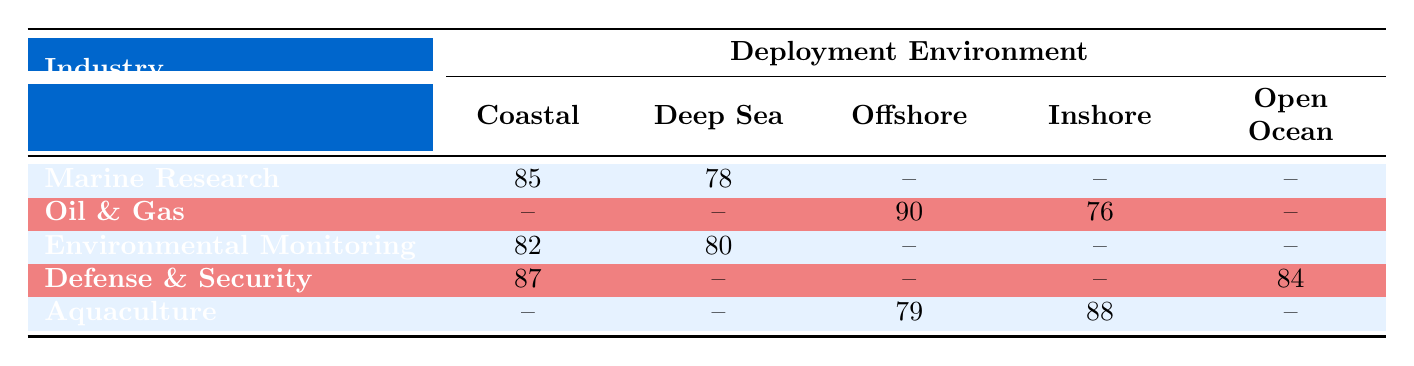What is the satisfaction rating for Marine Research in the Coastal environment? The table shows that the satisfaction rating for Marine Research under the Coastal deployment environment is 85.
Answer: 85 What is the satisfaction rating for Aquaculture in the Inshore environment? According to the table, Aquaculture has a satisfaction rating of 88 in the Inshore deployment environment.
Answer: 88 Which industry has the highest satisfaction rating in the Offshore environment? The table indicates that the Oil & Gas industry has a satisfaction rating of 90 in the Offshore deployment environment, which is the highest among all industries listed.
Answer: 90 What is the average satisfaction rating for the Environmental Monitoring industry? The satisfaction ratings for Environmental Monitoring are 82 (Coastal) and 80 (Deep Sea). Adding these gives 162, and dividing by 2 gives an average of 81.
Answer: 81 Is there a satisfaction rating recorded for Oil & Gas in the Coastal environment? The table shows no satisfaction rating listed for Oil & Gas in the Coastal environment, indicating that it is not applicable or data is not available.
Answer: No What is the difference between the satisfaction ratings of Defense & Security in the Coastal and Open Ocean environments? The rating for Defense & Security in the Coastal environment is 87, and in the Open Ocean environment is 84. The difference is 87 - 84 = 3.
Answer: 3 Which industries have data for both Coastal and Deep Sea environments? The table indicates only Marine Research and Environmental Monitoring have satisfaction ratings for both Coastal (Marine Research: 85, Environmental Monitoring: 82) and Deep Sea (Marine Research: 78, Environmental Monitoring: 80) environments.
Answer: Marine Research, Environmental Monitoring Is the satisfaction rating for Aquaculture lower in Offshore than in Inshore environments? The table highlights that Aquaculture has a satisfaction rating of 79 in the Offshore environment and 88 in the Inshore environment. Thus, the rating in Offshore is lower.
Answer: Yes What is the total of the satisfaction ratings for all industries in the Deep Sea environment? The total satisfaction ratings for the Deep Sea environment are 78 (Marine Research) + 80 (Environmental Monitoring) = 158, as there are no ratings listed for other industries.
Answer: 158 